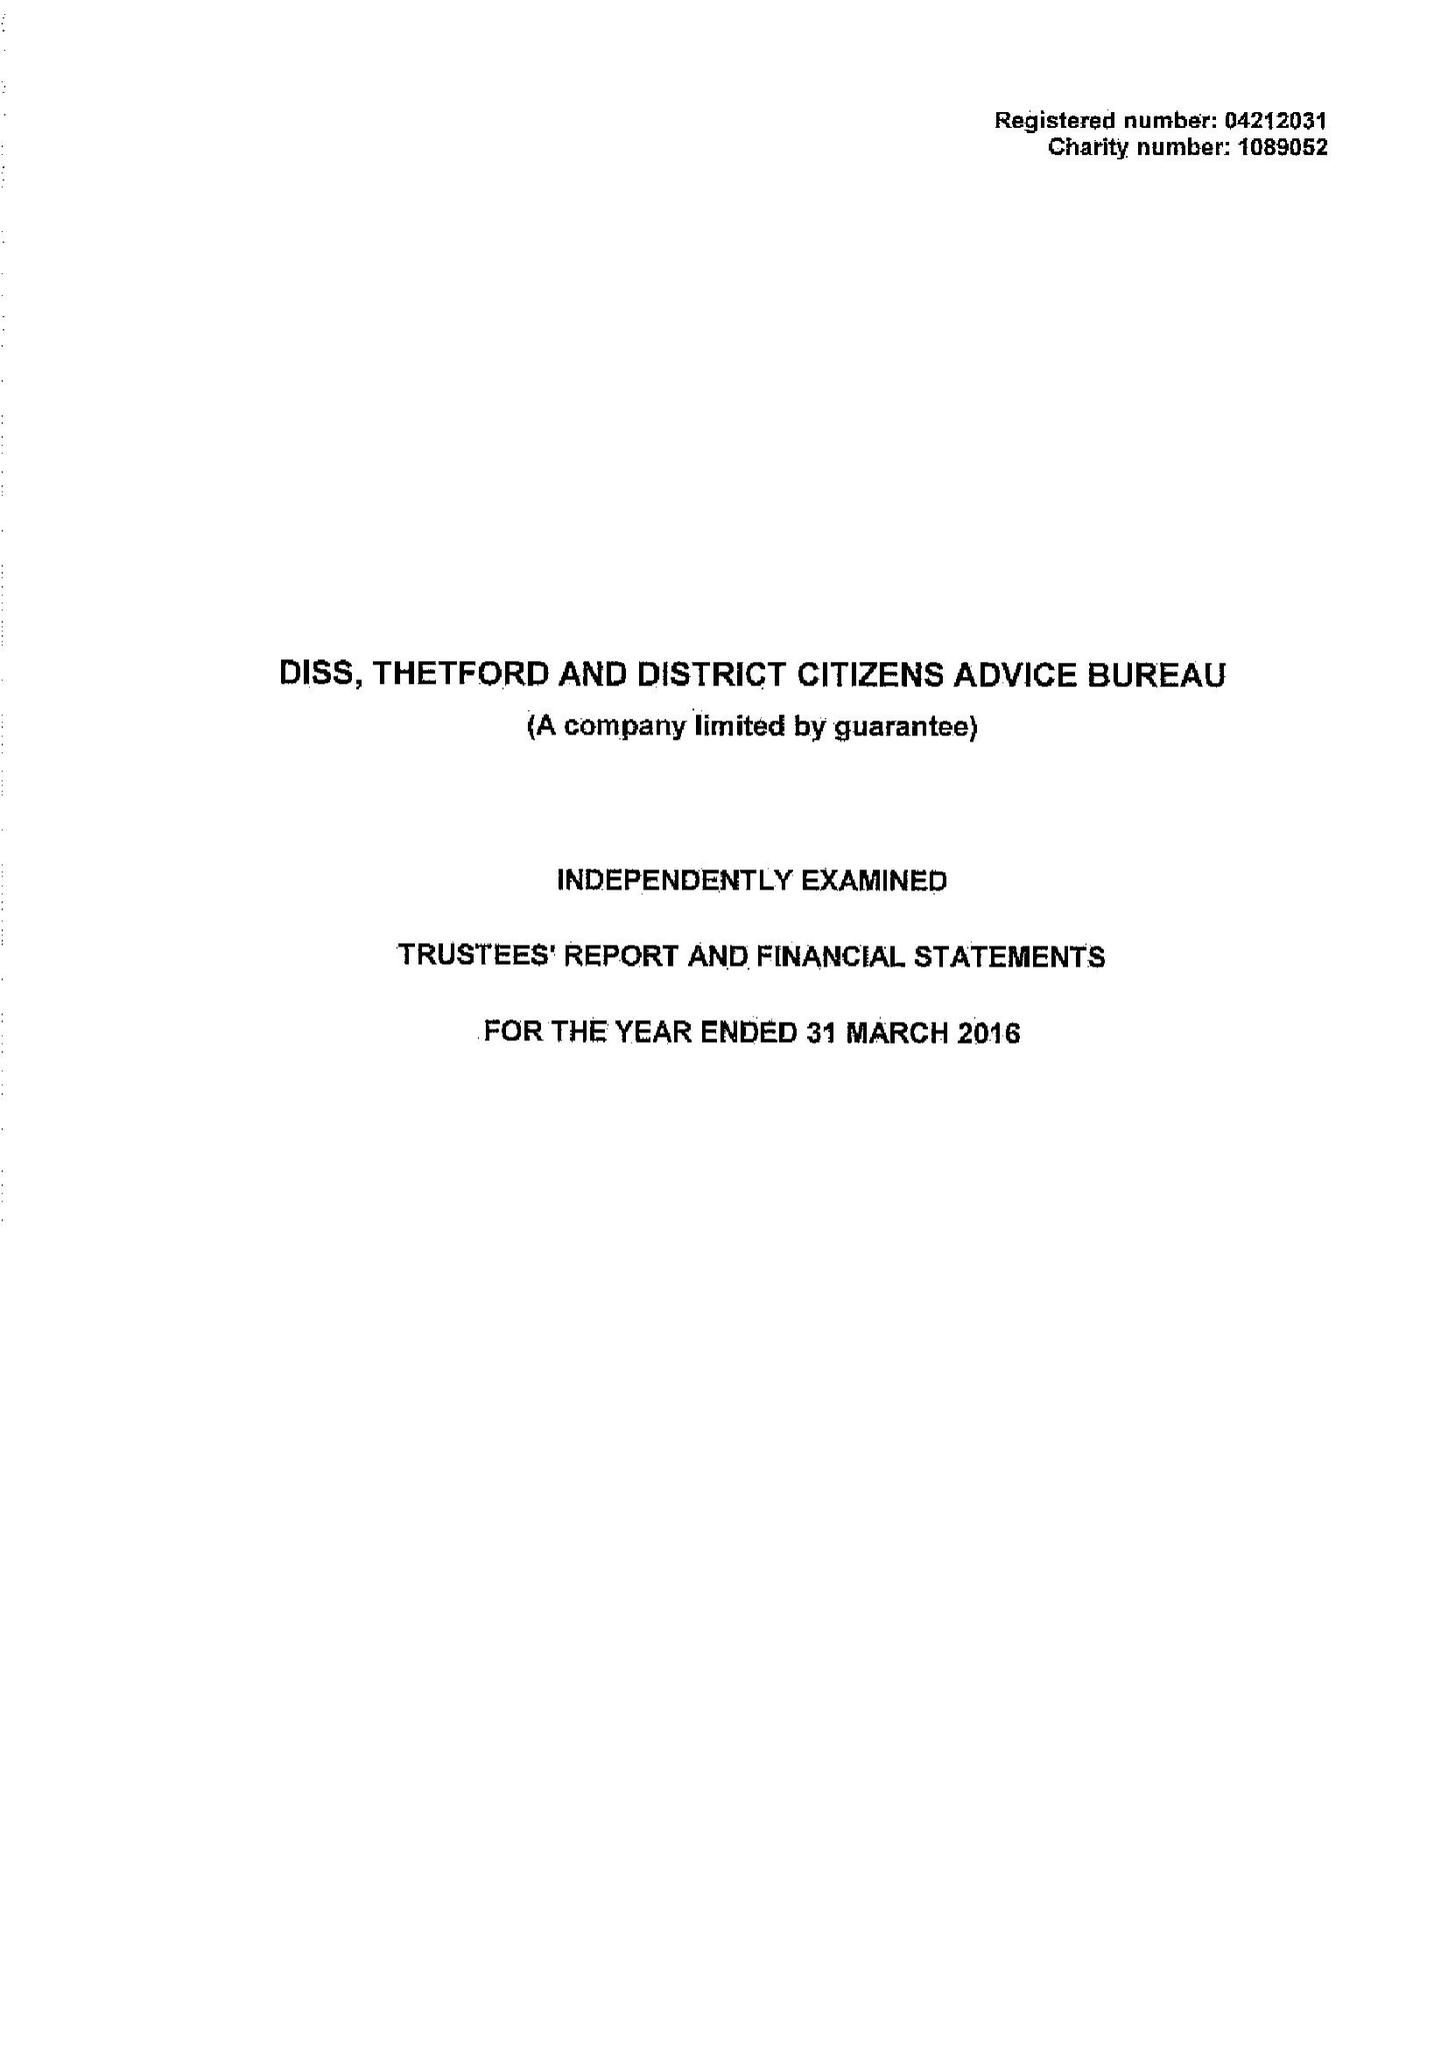What is the value for the address__street_line?
Answer the question using a single word or phrase. SHELFANGER ROAD 